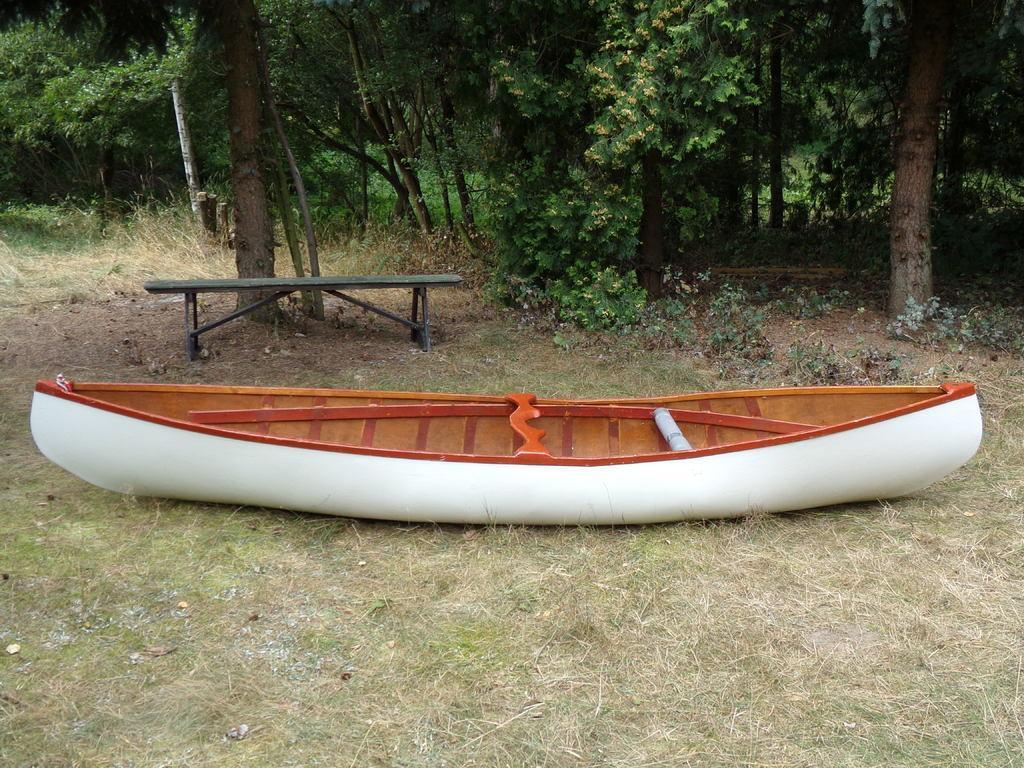Could you give a brief overview of what you see in this image? In the center of the image there is a white color boat on the grass surface. In the background of the image there are trees. There is a bench. 